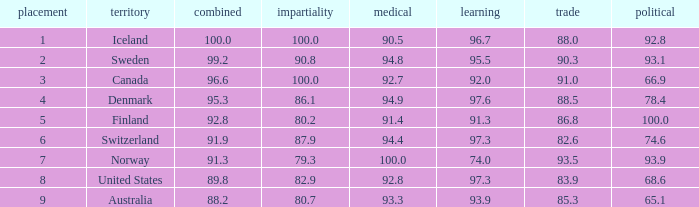What's the economics score with justice being 90.8 90.3. 